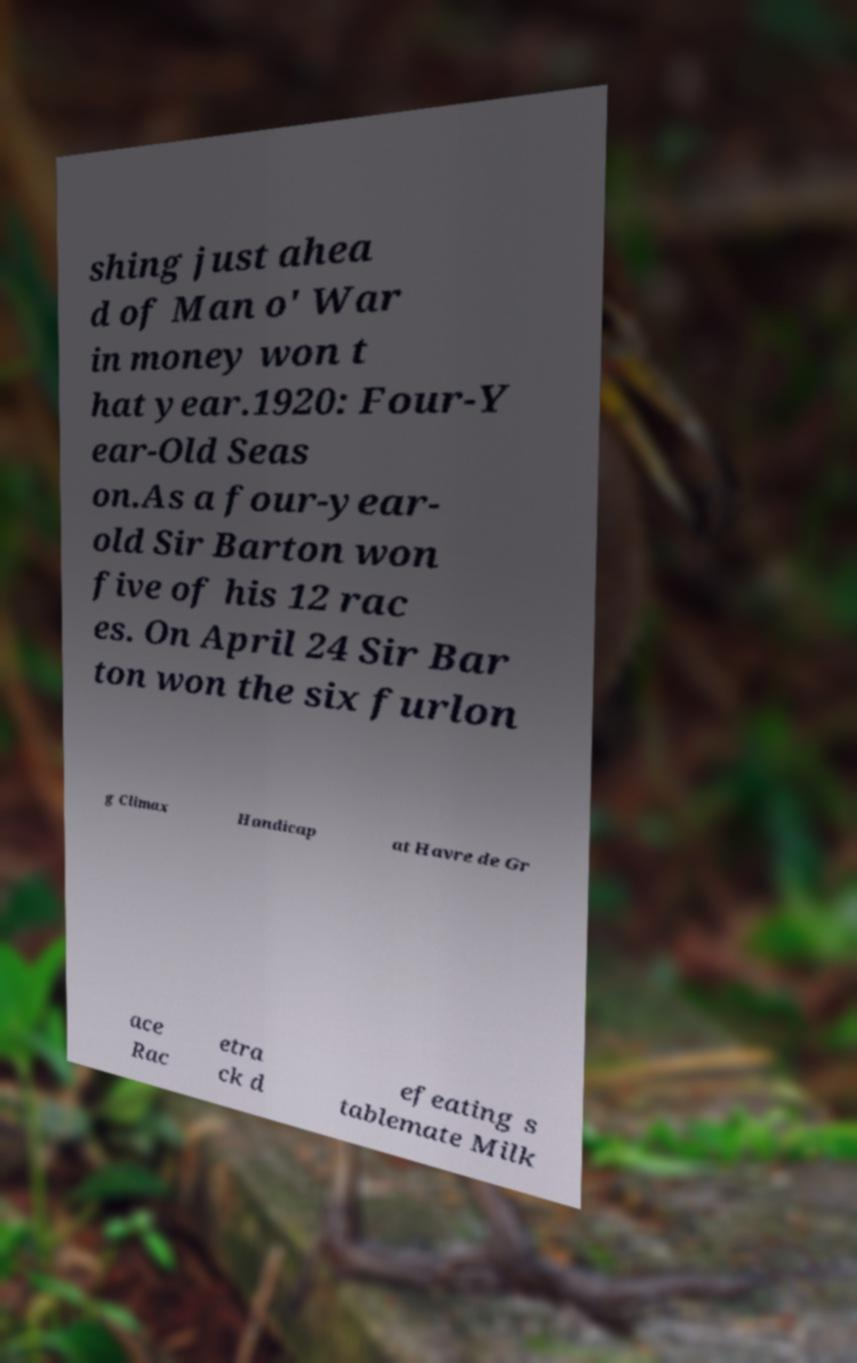What messages or text are displayed in this image? I need them in a readable, typed format. shing just ahea d of Man o' War in money won t hat year.1920: Four-Y ear-Old Seas on.As a four-year- old Sir Barton won five of his 12 rac es. On April 24 Sir Bar ton won the six furlon g Climax Handicap at Havre de Gr ace Rac etra ck d efeating s tablemate Milk 